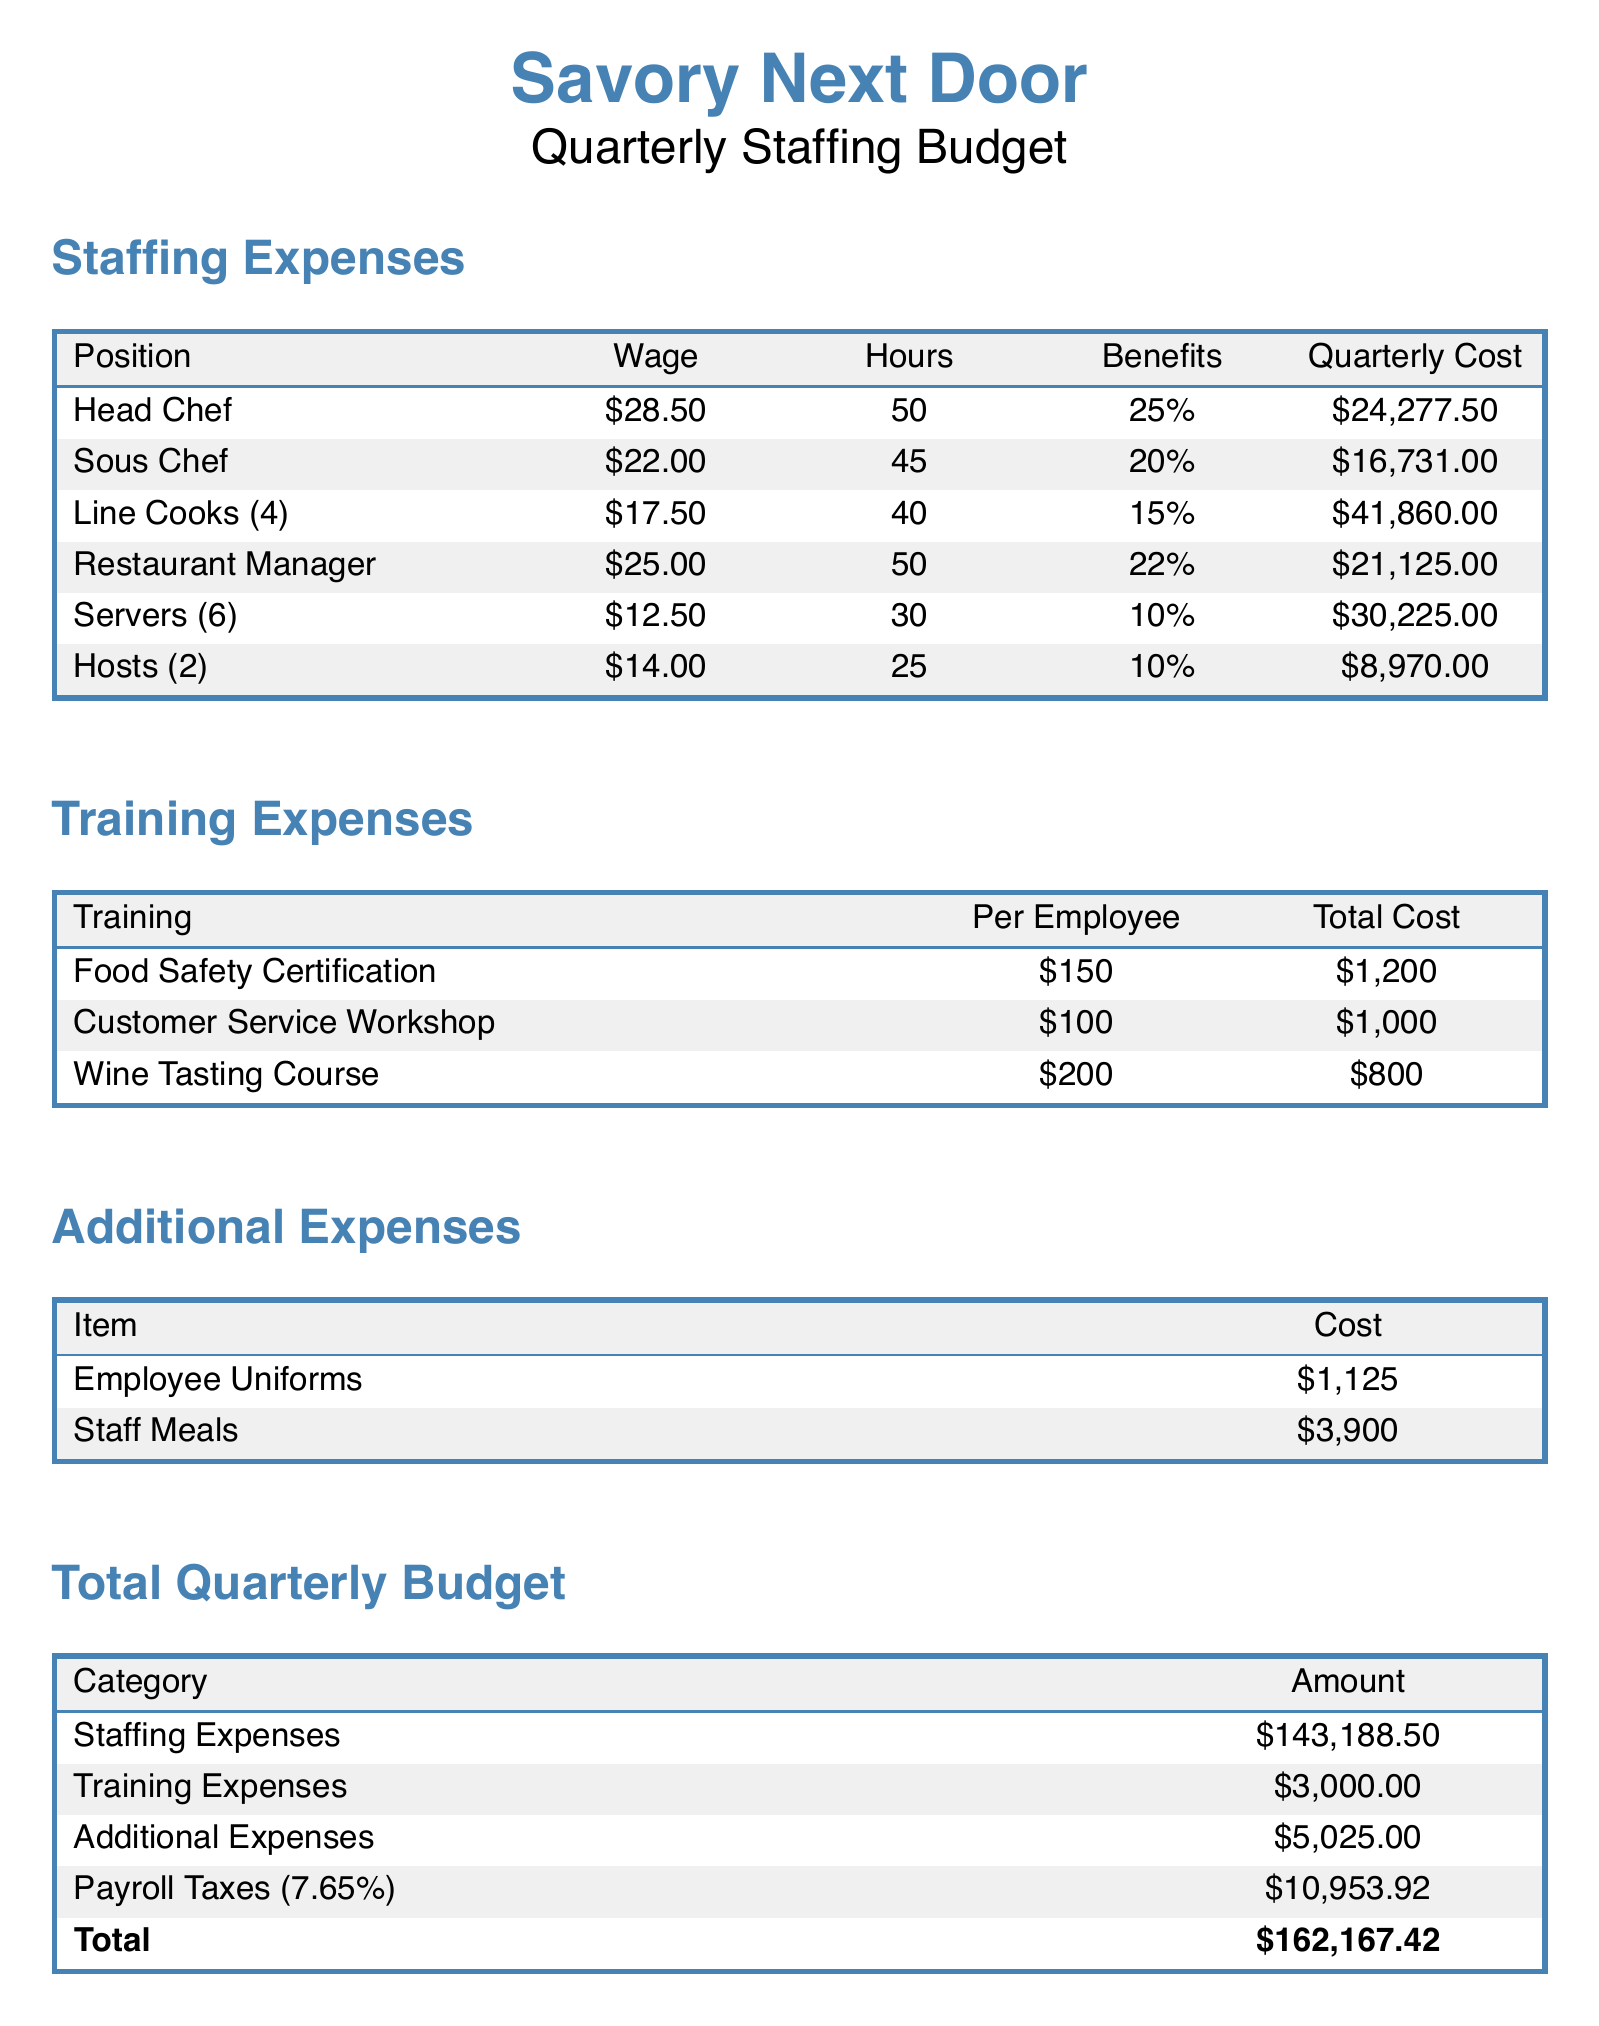What is the wage for the Head Chef? The Head Chef's wage is listed in the staffing expenses section of the document as $28.50 per hour.
Answer: $28.50 What is the total cost for Line Cooks? The total cost for Line Cooks is calculated by summing the wages, hours, and benefits, which results in $41,860.00.
Answer: $41,860.00 How many servers are there? The number of servers is explicitly mentioned in the staffing expenses section as 6.
Answer: 6 What is the percentage of benefits for the Sous Chef? The section on staffing expenses indicates that the benefits for the Sous Chef amount to 20%.
Answer: 20% What is the total for training expenses? The total for training expenses is shown at the end of the training expenses section as $3,000.00.
Answer: $3,000.00 What is the cost of employee uniforms? The document lists the cost of employee uniforms under additional expenses as $1,125.
Answer: $1,125 What is the total quarterly budget? The total quarterly budget is presented in the document as $162,167.42, which is the sum of all expense categories.
Answer: $162,167.42 What is the per employee cost for the Wine Tasting Course? The document provides the per employee cost for the Wine Tasting Course as $200.
Answer: $200 How much are the staff meals? The cost of staff meals is stated in the additional expenses section as $3,900.
Answer: $3,900 